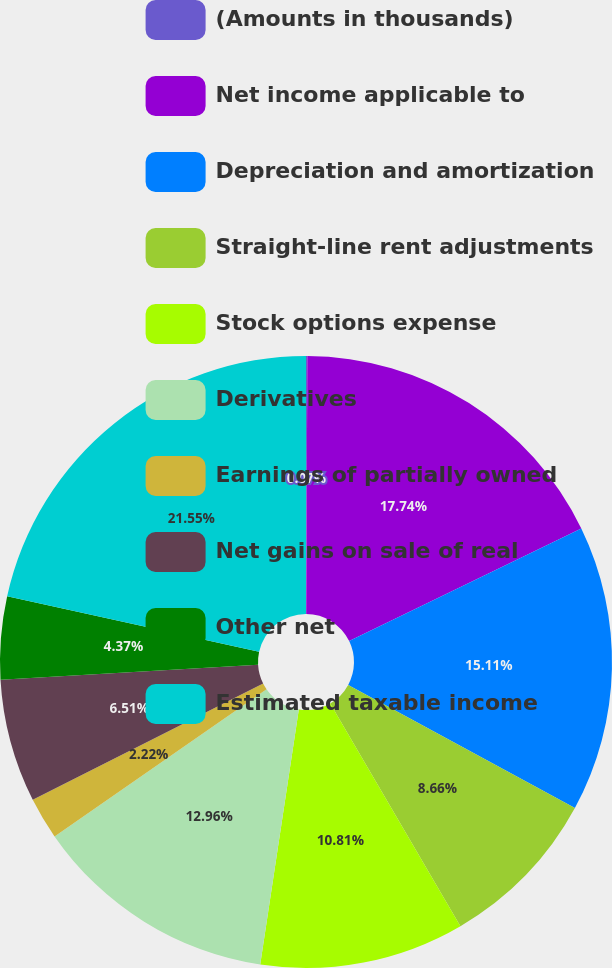<chart> <loc_0><loc_0><loc_500><loc_500><pie_chart><fcel>(Amounts in thousands)<fcel>Net income applicable to<fcel>Depreciation and amortization<fcel>Straight-line rent adjustments<fcel>Stock options expense<fcel>Derivatives<fcel>Earnings of partially owned<fcel>Net gains on sale of real<fcel>Other net<fcel>Estimated taxable income<nl><fcel>0.07%<fcel>17.74%<fcel>15.11%<fcel>8.66%<fcel>10.81%<fcel>12.96%<fcel>2.22%<fcel>6.51%<fcel>4.37%<fcel>21.55%<nl></chart> 